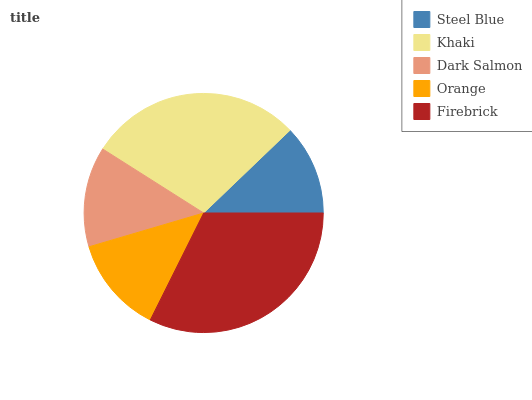Is Steel Blue the minimum?
Answer yes or no. Yes. Is Firebrick the maximum?
Answer yes or no. Yes. Is Khaki the minimum?
Answer yes or no. No. Is Khaki the maximum?
Answer yes or no. No. Is Khaki greater than Steel Blue?
Answer yes or no. Yes. Is Steel Blue less than Khaki?
Answer yes or no. Yes. Is Steel Blue greater than Khaki?
Answer yes or no. No. Is Khaki less than Steel Blue?
Answer yes or no. No. Is Dark Salmon the high median?
Answer yes or no. Yes. Is Dark Salmon the low median?
Answer yes or no. Yes. Is Firebrick the high median?
Answer yes or no. No. Is Firebrick the low median?
Answer yes or no. No. 